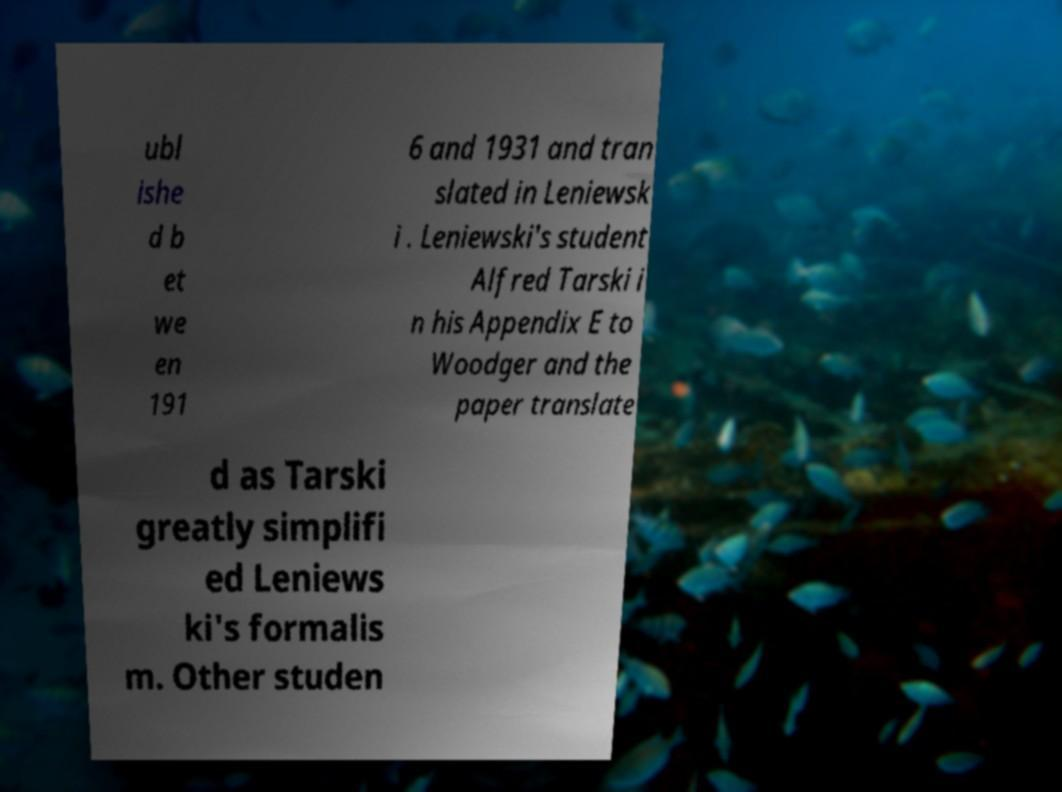Could you extract and type out the text from this image? ubl ishe d b et we en 191 6 and 1931 and tran slated in Leniewsk i . Leniewski's student Alfred Tarski i n his Appendix E to Woodger and the paper translate d as Tarski greatly simplifi ed Leniews ki's formalis m. Other studen 